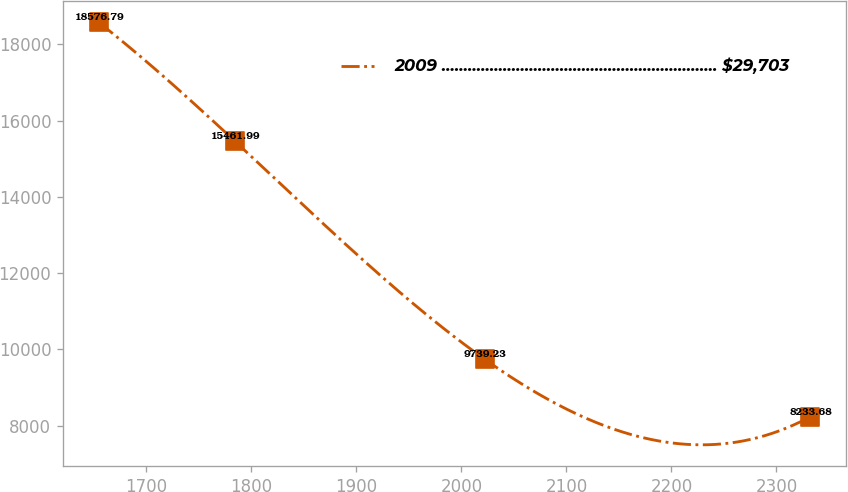Convert chart to OTSL. <chart><loc_0><loc_0><loc_500><loc_500><line_chart><ecel><fcel>2009 ............................................................... $29,703<nl><fcel>1654.53<fcel>18576.8<nl><fcel>1784.21<fcel>15462<nl><fcel>2022.28<fcel>9739.23<nl><fcel>2332.3<fcel>8233.68<nl></chart> 